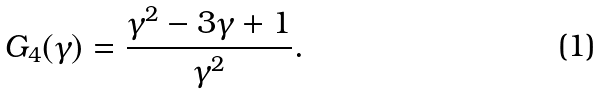<formula> <loc_0><loc_0><loc_500><loc_500>G _ { 4 } ( \gamma ) = \frac { \gamma ^ { 2 } - 3 \gamma + 1 } { \gamma ^ { 2 } } .</formula> 